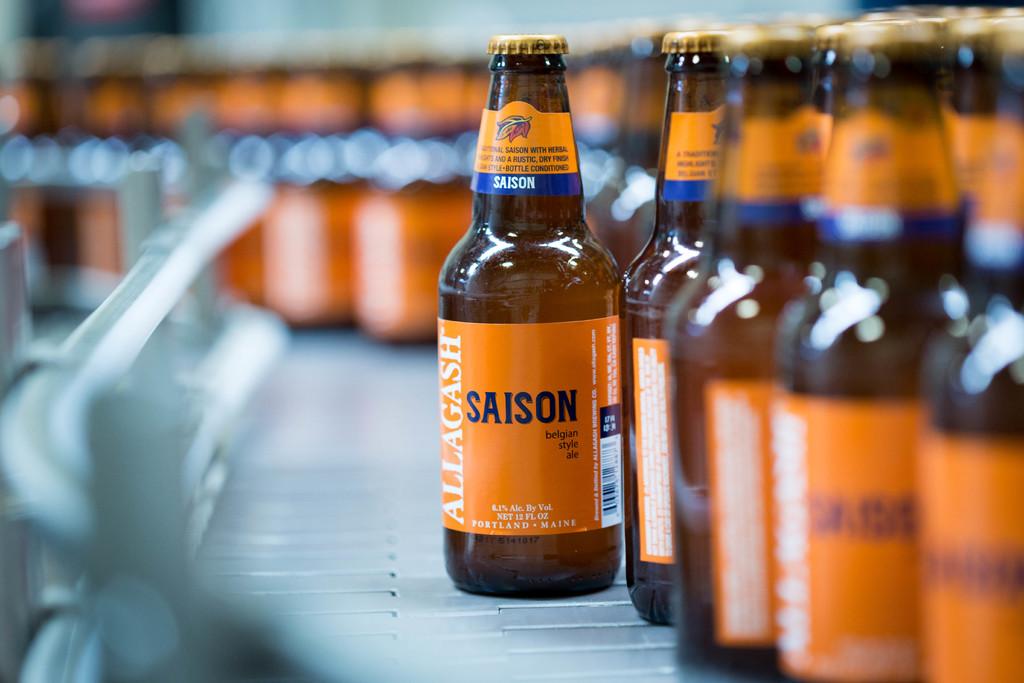In what city and state is this drink made in?
Offer a terse response. Portland maine. What is the brand of the ale?
Give a very brief answer. Allagash. 